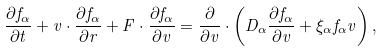Convert formula to latex. <formula><loc_0><loc_0><loc_500><loc_500>\frac { \partial f _ { \alpha } } { \partial t } + v \cdot \frac { \partial f _ { \alpha } } { \partial r } + F \cdot \frac { \partial f _ { \alpha } } { \partial v } = \frac { \partial } { \partial v } \cdot \left ( D _ { \alpha } \frac { \partial f _ { \alpha } } { \partial v } + \xi _ { \alpha } f _ { \alpha } v \right ) ,</formula> 